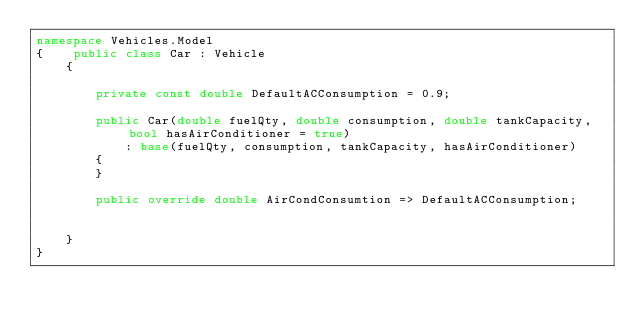Convert code to text. <code><loc_0><loc_0><loc_500><loc_500><_C#_>namespace Vehicles.Model
{    public class Car : Vehicle
    {
        
        private const double DefaultACConsumption = 0.9;

        public Car(double fuelQty, double consumption, double tankCapacity, bool hasAirConditioner = true) 
            : base(fuelQty, consumption, tankCapacity, hasAirConditioner)
        {
        }

        public override double AirCondConsumtion => DefaultACConsumption;


    }
}
</code> 